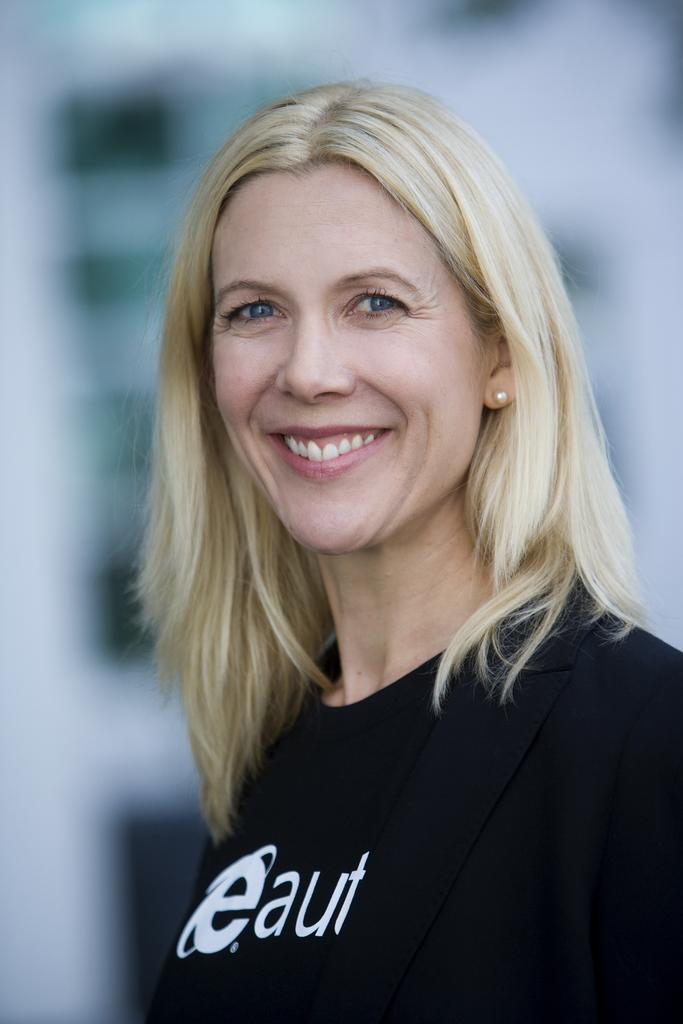What is the main subject of the image? The main subject of the image is a woman. What is the woman wearing in the image? The woman is wearing a black t-shirt in the image. Are there any accessories visible on the woman? Yes, the woman is wearing earrings in the image. What is the woman's facial expression in the image? The woman is smiling in the image. What type of pet is the woman playing with in the image? There is no pet present in the image, and the woman is not shown playing with any pet. What is the title of the book the woman is reading in the image? There is no book present in the image, so there is no title to mention. 